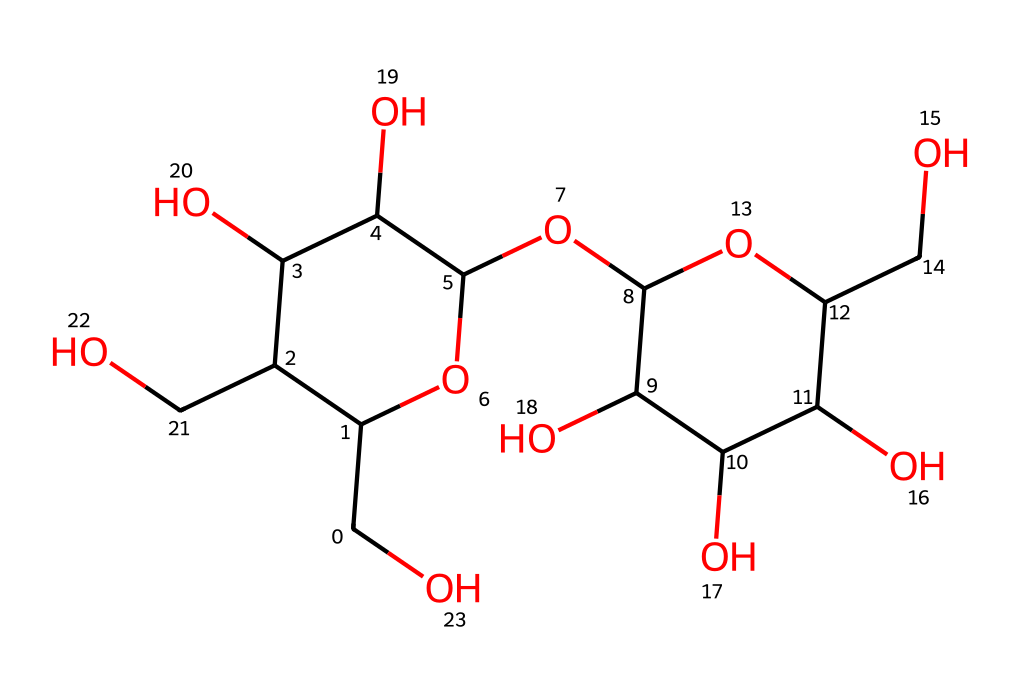What is the backbone structure of maltose? The backbone of maltose consists of two glucose units linked by a glycosidic bond. Identifying the primary structure involves looking for the repeating glucose units connected by oxygen atoms that indicate their linkage.
Answer: two glucose units How many oxygen atoms are present in the structure of maltose? By counting the oxygen atoms in the SMILES representation, we identify that there are 9 oxygen atoms present. This is done by systematically surveying the entire structure for "O" characters.
Answer: nine What type of glycosidic linkage is found in maltose? Maltose features an alpha-1,4 glycosidic linkage, which is determined by examining the configuration of the carbon atoms involved in the linkage between the two glucose rings.
Answer: alpha-1,4 What is the molecular formula of maltose? The molecular formula for maltose can be derived from the total number of each type of atom in the chemical structure, leading to the formula C12H22O11 based on the counted atoms.
Answer: C12H22O11 How many carbon atoms are in maltose? Analyzing the SMILES representation, we find a total of 12 carbon atoms present in maltose due to the configuration of its glucose units and their interlinkages.
Answer: twelve What role do carbohydrates like maltose play in brewing? Carbohydrates like maltose serve as fermentable sugars during brewing, providing energy for yeast fermentation, which is essential for alcohol production. This is based on the fundamental role of sugars in fermentation within brewing processes.
Answer: fermentable sugars 